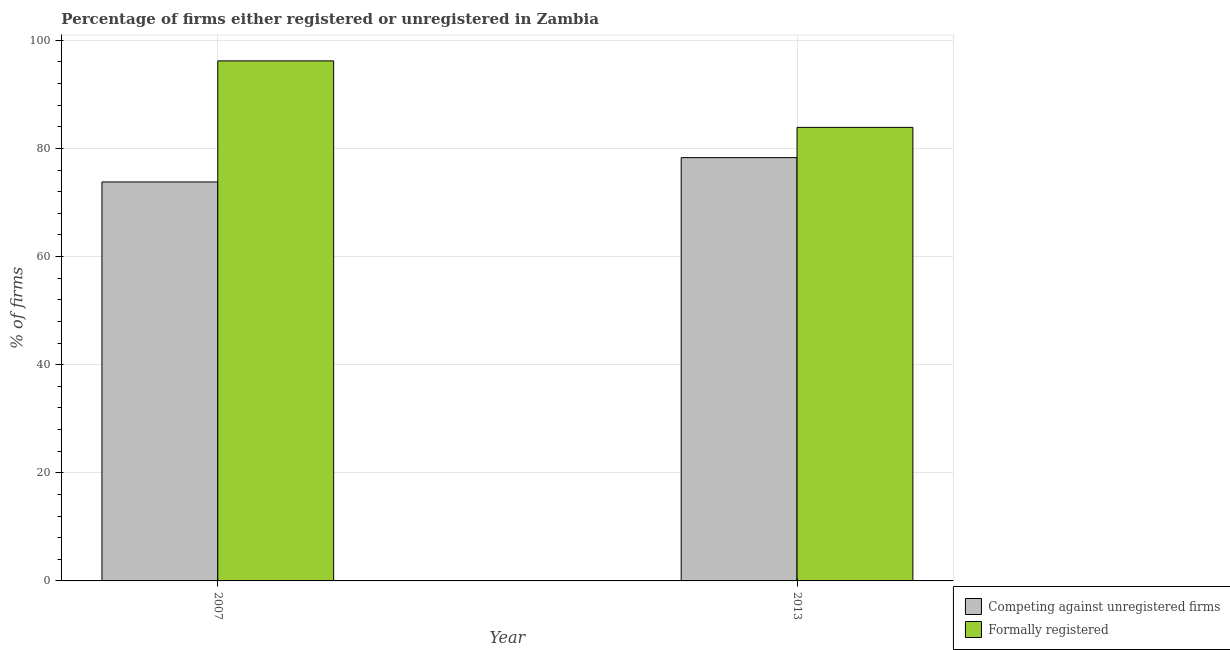Are the number of bars per tick equal to the number of legend labels?
Keep it short and to the point. Yes. Are the number of bars on each tick of the X-axis equal?
Make the answer very short. Yes. How many bars are there on the 1st tick from the right?
Provide a succinct answer. 2. What is the label of the 1st group of bars from the left?
Ensure brevity in your answer.  2007. What is the percentage of registered firms in 2007?
Offer a very short reply. 73.8. Across all years, what is the maximum percentage of registered firms?
Your answer should be compact. 78.3. Across all years, what is the minimum percentage of registered firms?
Give a very brief answer. 73.8. In which year was the percentage of formally registered firms maximum?
Your answer should be very brief. 2007. In which year was the percentage of registered firms minimum?
Offer a very short reply. 2007. What is the total percentage of registered firms in the graph?
Your response must be concise. 152.1. What is the difference between the percentage of formally registered firms in 2013 and the percentage of registered firms in 2007?
Keep it short and to the point. -12.3. What is the average percentage of registered firms per year?
Keep it short and to the point. 76.05. In how many years, is the percentage of registered firms greater than 72 %?
Your answer should be very brief. 2. What is the ratio of the percentage of formally registered firms in 2007 to that in 2013?
Your answer should be compact. 1.15. In how many years, is the percentage of registered firms greater than the average percentage of registered firms taken over all years?
Make the answer very short. 1. What does the 1st bar from the left in 2013 represents?
Offer a terse response. Competing against unregistered firms. What does the 2nd bar from the right in 2013 represents?
Keep it short and to the point. Competing against unregistered firms. How many years are there in the graph?
Offer a terse response. 2. Does the graph contain any zero values?
Offer a very short reply. No. Where does the legend appear in the graph?
Give a very brief answer. Bottom right. How are the legend labels stacked?
Make the answer very short. Vertical. What is the title of the graph?
Provide a succinct answer. Percentage of firms either registered or unregistered in Zambia. Does "All education staff compensation" appear as one of the legend labels in the graph?
Your answer should be very brief. No. What is the label or title of the X-axis?
Keep it short and to the point. Year. What is the label or title of the Y-axis?
Your response must be concise. % of firms. What is the % of firms of Competing against unregistered firms in 2007?
Keep it short and to the point. 73.8. What is the % of firms of Formally registered in 2007?
Provide a succinct answer. 96.2. What is the % of firms of Competing against unregistered firms in 2013?
Provide a succinct answer. 78.3. What is the % of firms in Formally registered in 2013?
Keep it short and to the point. 83.9. Across all years, what is the maximum % of firms in Competing against unregistered firms?
Offer a terse response. 78.3. Across all years, what is the maximum % of firms in Formally registered?
Ensure brevity in your answer.  96.2. Across all years, what is the minimum % of firms in Competing against unregistered firms?
Offer a very short reply. 73.8. Across all years, what is the minimum % of firms in Formally registered?
Make the answer very short. 83.9. What is the total % of firms of Competing against unregistered firms in the graph?
Keep it short and to the point. 152.1. What is the total % of firms in Formally registered in the graph?
Provide a succinct answer. 180.1. What is the difference between the % of firms in Competing against unregistered firms in 2007 and that in 2013?
Your response must be concise. -4.5. What is the difference between the % of firms in Formally registered in 2007 and that in 2013?
Keep it short and to the point. 12.3. What is the average % of firms in Competing against unregistered firms per year?
Your answer should be very brief. 76.05. What is the average % of firms in Formally registered per year?
Keep it short and to the point. 90.05. In the year 2007, what is the difference between the % of firms in Competing against unregistered firms and % of firms in Formally registered?
Provide a succinct answer. -22.4. What is the ratio of the % of firms of Competing against unregistered firms in 2007 to that in 2013?
Offer a very short reply. 0.94. What is the ratio of the % of firms of Formally registered in 2007 to that in 2013?
Your answer should be compact. 1.15. 